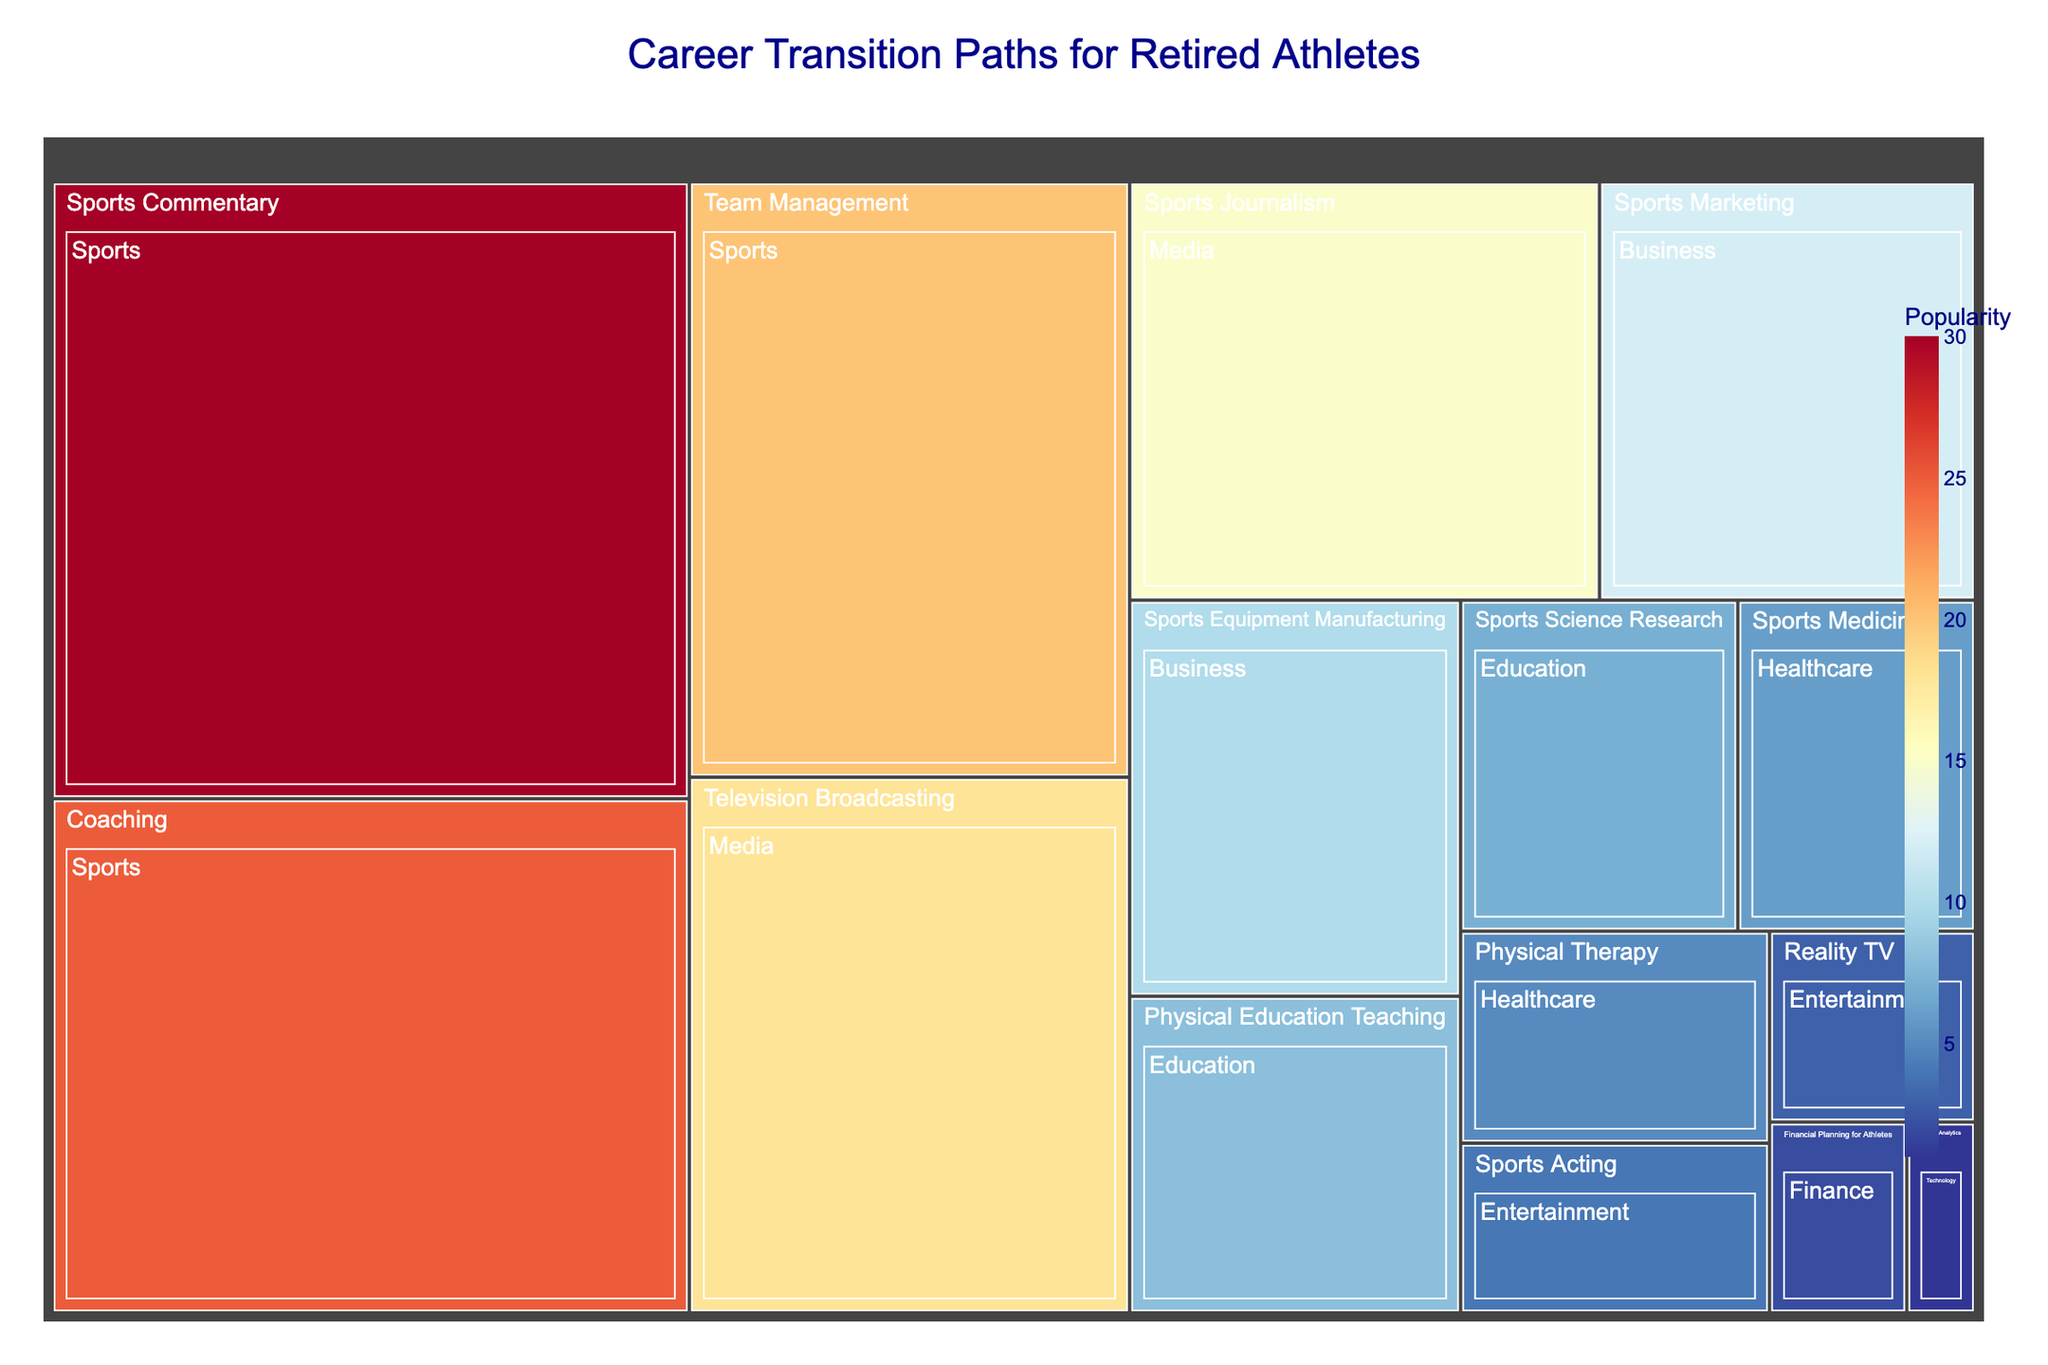What's the title of the treemap? The title is generally located at the top of the treemap and describes the main purpose of the figure.
Answer: Career Transition Paths for Retired Athletes Which sector within the Sports industry has the highest popularity? By examining the Sports industry section and identifying the segment with the largest area, we see that 'Sports Commentary' has the largest area within Sports.
Answer: Sports Commentary How many sectors are there in the Media industry? Each rectangle or nested section represents a different sector within an industry. By counting the sections under the Media label, we find two sectors: 'Television Broadcasting' and 'Sports Journalism'.
Answer: 2 What's the combined popularity of all sectors within Healthcare? Sum the popularity values of the 'Sports Medicine' and 'Physical Therapy' sectors, which are 6 and 5 respectively.
Answer: 11 Which sector has the least popularity overall? Comparing all sectors in the treemap, the smallest rectangle corresponds to the 'Sports Analytics' sector in Technology.
Answer: Sports Analytics What is the popularity difference between Team Management in Sports and Physical Education Teaching in Education? Look at the popularity values for 'Team Management' (20) and 'Physical Education Teaching' (8), then subtract the smaller value from the larger one: 20 - 8 = 12.
Answer: 12 Which industry has the most sectors represented in the treemap? Count the number of sectors within each industry. The Sports industry has the most with three sectors: 'Sports Commentary', 'Coaching', and 'Team Management'.
Answer: Sports Arrange the sectors in Business by their popularity in descending order. Look at the sectors within Business and order them by the popularity values: 'Sports Marketing' (12) and 'Sports Equipment Manufacturing' (10).
Answer: 1. Sports Marketing, 2. Sports Equipment Manufacturing Which sector in the Education industry has higher popularity, and by how much? Compare 'Physical Education Teaching' (8) and 'Sports Science Research' (7); subtract the smaller from the larger: 8 - 7 = 1.
Answer: Physical Education Teaching by 1 What is the total popularity of all sectors under the Entertainment industry? Sum the popularity values for 'Sports Acting' (4) and 'Reality TV' (3): 4 + 3 = 7.
Answer: 7 